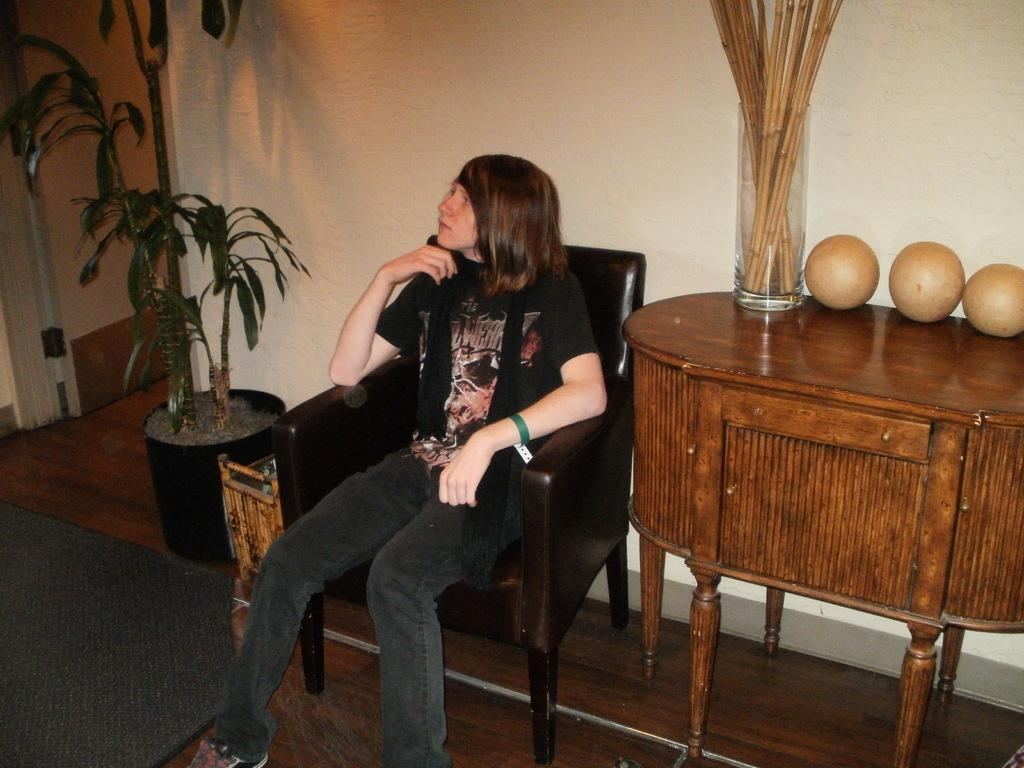What is the color of the wall in the image? The wall in the image is white. What can be seen besides the wall in the image? There is a plant, a chair, sticks, and balls visible in the image. What is the girl in the image doing? The girl is sitting on the chair in the image. What type of servant is attending to the girl in the image? There is no servant present in the image; it only shows a girl sitting on a chair with other objects nearby. 